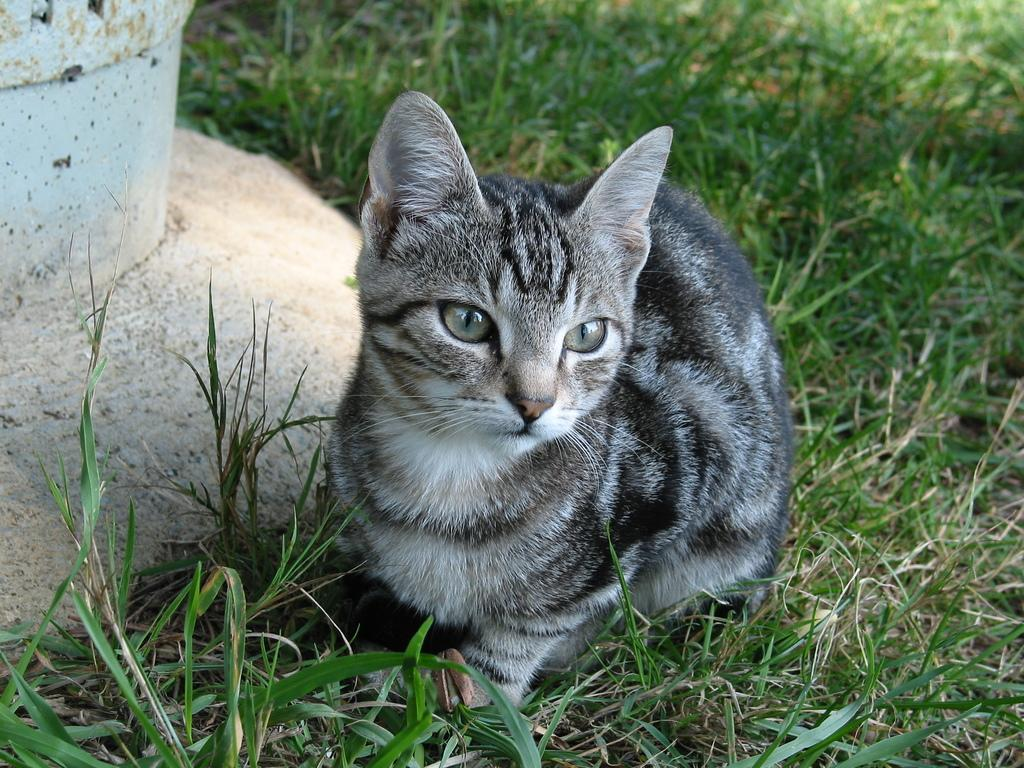What type of animal is in the image? There is a cat in the image. Can you describe the appearance of the cat? The cat is white and black in color. Where is the cat located in the image? The cat is sitting on the grass. What can be seen in the background of the image? There is a white color pillar in the background of the image. What type of seed is the cat planting in the image? There is no seed present in the image, nor is the cat shown planting anything. 